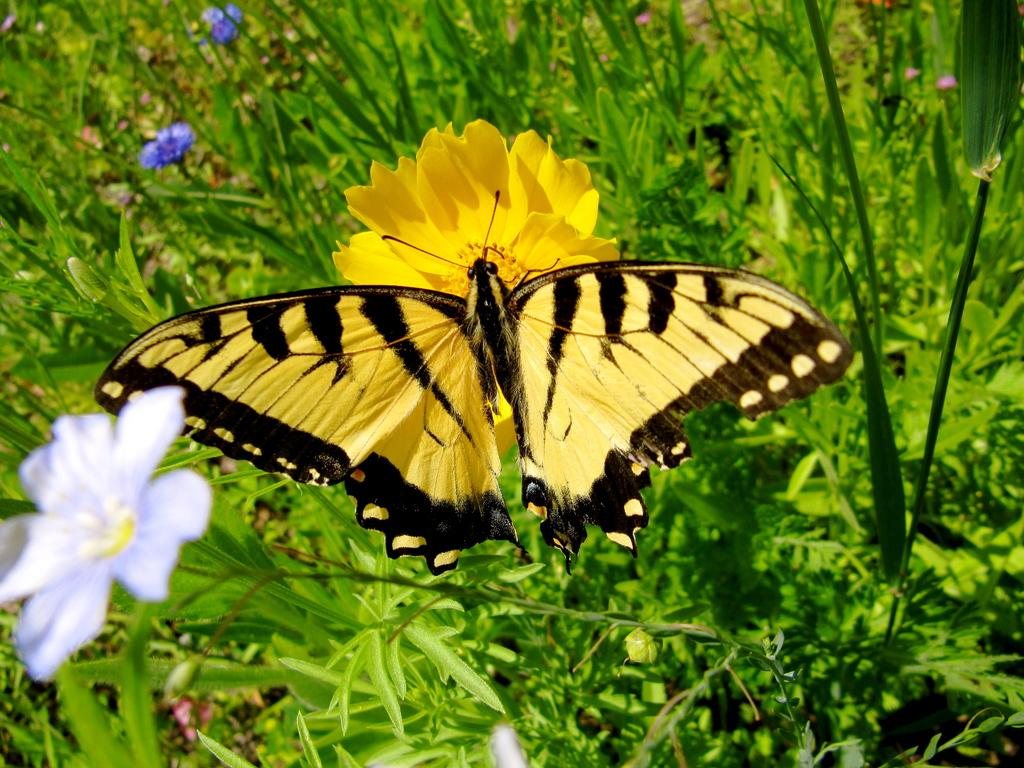What type of living organisms can be seen in the image? Plants and flowers are visible in the image. What colors are the flowers in the image? The flowers are yellow, blue, and purple in color. What other creature can be seen in the image besides the plants and flowers? There is a butterfly in the image. What colors are the butterfly in the image? The butterfly is yellow and black in color. How does the beginner learn to change the gate in the image? There is no gate or learning process depicted in the image; it features plants, flowers, and a butterfly. 